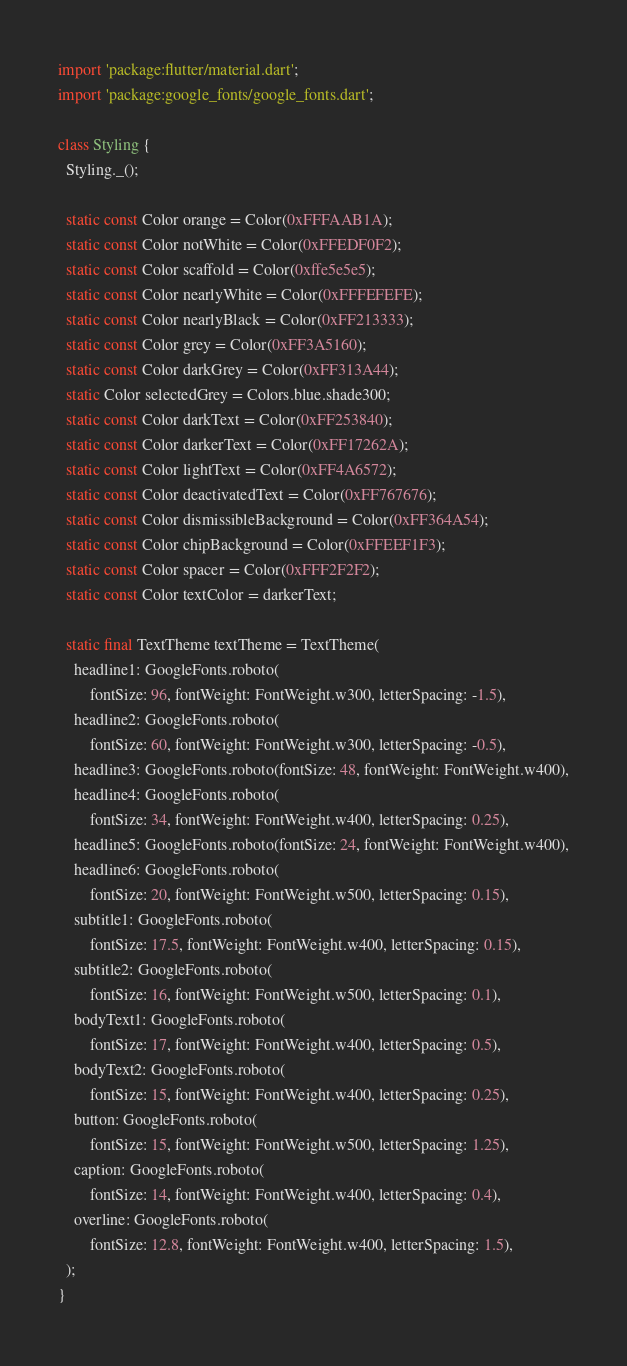Convert code to text. <code><loc_0><loc_0><loc_500><loc_500><_Dart_>import 'package:flutter/material.dart';
import 'package:google_fonts/google_fonts.dart';

class Styling {
  Styling._();

  static const Color orange = Color(0xFFFAAB1A);
  static const Color notWhite = Color(0xFFEDF0F2);
  static const Color scaffold = Color(0xffe5e5e5);
  static const Color nearlyWhite = Color(0xFFFEFEFE);
  static const Color nearlyBlack = Color(0xFF213333);
  static const Color grey = Color(0xFF3A5160);
  static const Color darkGrey = Color(0xFF313A44);
  static Color selectedGrey = Colors.blue.shade300;
  static const Color darkText = Color(0xFF253840);
  static const Color darkerText = Color(0xFF17262A);
  static const Color lightText = Color(0xFF4A6572);
  static const Color deactivatedText = Color(0xFF767676);
  static const Color dismissibleBackground = Color(0xFF364A54);
  static const Color chipBackground = Color(0xFFEEF1F3);
  static const Color spacer = Color(0xFFF2F2F2);
  static const Color textColor = darkerText;

  static final TextTheme textTheme = TextTheme(
    headline1: GoogleFonts.roboto(
        fontSize: 96, fontWeight: FontWeight.w300, letterSpacing: -1.5),
    headline2: GoogleFonts.roboto(
        fontSize: 60, fontWeight: FontWeight.w300, letterSpacing: -0.5),
    headline3: GoogleFonts.roboto(fontSize: 48, fontWeight: FontWeight.w400),
    headline4: GoogleFonts.roboto(
        fontSize: 34, fontWeight: FontWeight.w400, letterSpacing: 0.25),
    headline5: GoogleFonts.roboto(fontSize: 24, fontWeight: FontWeight.w400),
    headline6: GoogleFonts.roboto(
        fontSize: 20, fontWeight: FontWeight.w500, letterSpacing: 0.15),
    subtitle1: GoogleFonts.roboto(
        fontSize: 17.5, fontWeight: FontWeight.w400, letterSpacing: 0.15),
    subtitle2: GoogleFonts.roboto(
        fontSize: 16, fontWeight: FontWeight.w500, letterSpacing: 0.1),
    bodyText1: GoogleFonts.roboto(
        fontSize: 17, fontWeight: FontWeight.w400, letterSpacing: 0.5),
    bodyText2: GoogleFonts.roboto(
        fontSize: 15, fontWeight: FontWeight.w400, letterSpacing: 0.25),
    button: GoogleFonts.roboto(
        fontSize: 15, fontWeight: FontWeight.w500, letterSpacing: 1.25),
    caption: GoogleFonts.roboto(
        fontSize: 14, fontWeight: FontWeight.w400, letterSpacing: 0.4),
    overline: GoogleFonts.roboto(
        fontSize: 12.8, fontWeight: FontWeight.w400, letterSpacing: 1.5),
  );
}
</code> 